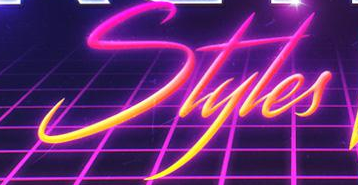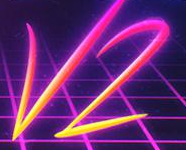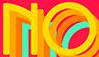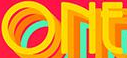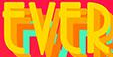Read the text from these images in sequence, separated by a semicolon. Styles; V2; NO; ONE; EVER 